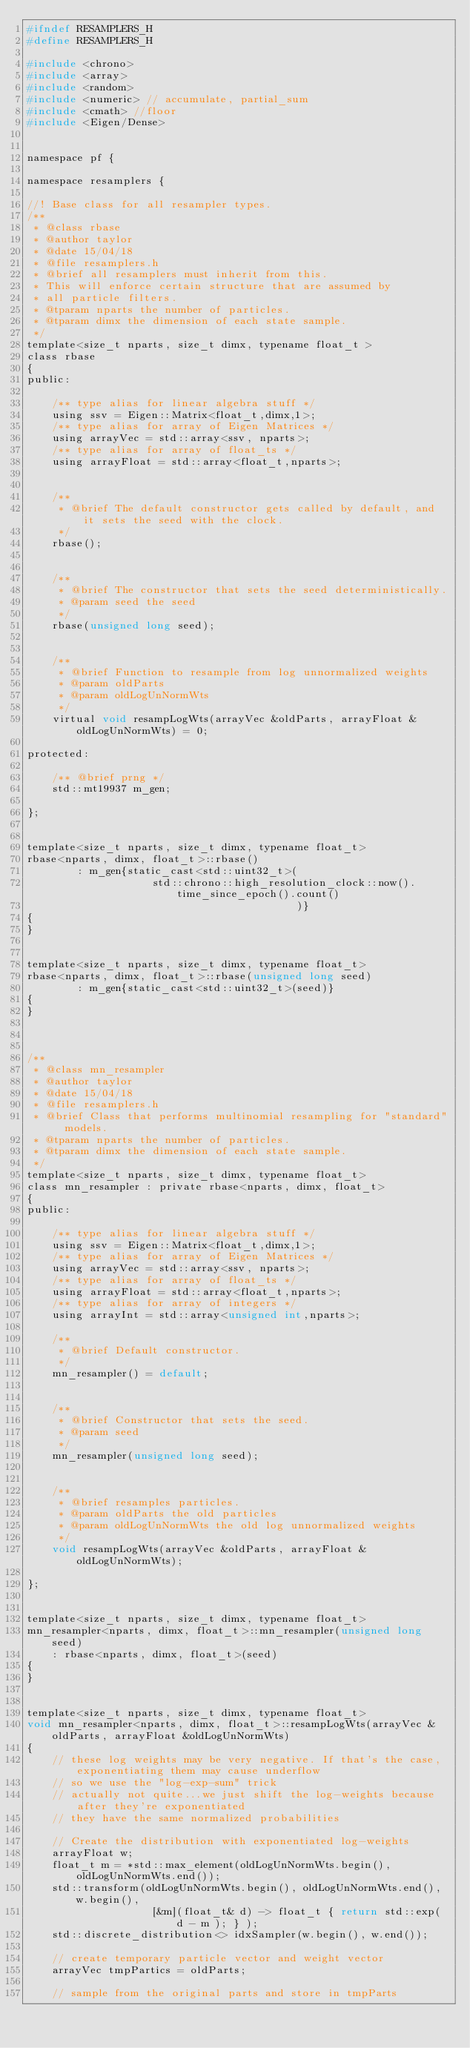Convert code to text. <code><loc_0><loc_0><loc_500><loc_500><_C_>#ifndef RESAMPLERS_H
#define RESAMPLERS_H

#include <chrono>
#include <array>
#include <random>
#include <numeric> // accumulate, partial_sum
#include <cmath> //floor
#include <Eigen/Dense>


namespace pf {

namespace resamplers {

//! Base class for all resampler types.
/**
 * @class rbase
 * @author taylor
 * @date 15/04/18
 * @file resamplers.h
 * @brief all resamplers must inherit from this. 
 * This will enforce certain structure that are assumed by 
 * all particle filters.
 * @tparam nparts the number of particles.
 * @tparam dimx the dimension of each state sample.
 */
template<size_t nparts, size_t dimx, typename float_t >
class rbase
{
public:

    /** type alias for linear algebra stuff */
    using ssv = Eigen::Matrix<float_t,dimx,1>;
    /** type alias for array of Eigen Matrices */
    using arrayVec = std::array<ssv, nparts>;
    /** type alias for array of float_ts */
    using arrayFloat = std::array<float_t,nparts>;


    /**
     * @brief The default constructor gets called by default, and it sets the seed with the clock. 
     */
    rbase();


    /**
     * @brief The constructor that sets the seed deterministically. 
     * @param seed the seed 
     */
    rbase(unsigned long seed);


    /**
     * @brief Function to resample from log unnormalized weights
     * @param oldParts
     * @param oldLogUnNormWts
     */
    virtual void resampLogWts(arrayVec &oldParts, arrayFloat &oldLogUnNormWts) = 0;

protected:

    /** @brief prng */
    std::mt19937 m_gen;

};


template<size_t nparts, size_t dimx, typename float_t>
rbase<nparts, dimx, float_t>::rbase() 
        : m_gen{static_cast<std::uint32_t>(
                    std::chrono::high_resolution_clock::now().time_since_epoch().count()
                                           )}
{
}


template<size_t nparts, size_t dimx, typename float_t>
rbase<nparts, dimx, float_t>::rbase(unsigned long seed) 
        : m_gen{static_cast<std::uint32_t>(seed)}
{
}



/**
 * @class mn_resampler
 * @author taylor
 * @date 15/04/18
 * @file resamplers.h
 * @brief Class that performs multinomial resampling for "standard" models.
 * @tparam nparts the number of particles.
 * @tparam dimx the dimension of each state sample.
 */
template<size_t nparts, size_t dimx, typename float_t>
class mn_resampler : private rbase<nparts, dimx, float_t>
{
public:

    /** type alias for linear algebra stuff */
    using ssv = Eigen::Matrix<float_t,dimx,1>;
    /** type alias for array of Eigen Matrices */
    using arrayVec = std::array<ssv, nparts>;
    /** type alias for array of float_ts */
    using arrayFloat = std::array<float_t,nparts>;
    /** type alias for array of integers */
    using arrayInt = std::array<unsigned int,nparts>;

    /**
     * @brief Default constructor. 
     */
    mn_resampler() = default;


    /**
     * @brief Constructor that sets the seed.
     * @param seed
     */
    mn_resampler(unsigned long seed);
    
    
    /**
     * @brief resamples particles.
     * @param oldParts the old particles
     * @param oldLogUnNormWts the old log unnormalized weights
     */
    void resampLogWts(arrayVec &oldParts, arrayFloat &oldLogUnNormWts);
    
};


template<size_t nparts, size_t dimx, typename float_t>
mn_resampler<nparts, dimx, float_t>::mn_resampler(unsigned long seed)
    : rbase<nparts, dimx, float_t>(seed)
{
}


template<size_t nparts, size_t dimx, typename float_t>
void mn_resampler<nparts, dimx, float_t>::resampLogWts(arrayVec &oldParts, arrayFloat &oldLogUnNormWts)
{
    // these log weights may be very negative. If that's the case, exponentiating them may cause underflow
    // so we use the "log-exp-sum" trick
    // actually not quite...we just shift the log-weights because after they're exponentiated
    // they have the same normalized probabilities
       
    // Create the distribution with exponentiated log-weights
    arrayFloat w;
    float_t m = *std::max_element(oldLogUnNormWts.begin(), oldLogUnNormWts.end());
    std::transform(oldLogUnNormWts.begin(), oldLogUnNormWts.end(), w.begin(), 
                    [&m](float_t& d) -> float_t { return std::exp( d - m ); } );
    std::discrete_distribution<> idxSampler(w.begin(), w.end());
    
    // create temporary particle vector and weight vector
    arrayVec tmpPartics = oldParts; 
    
    // sample from the original parts and store in tmpParts</code> 